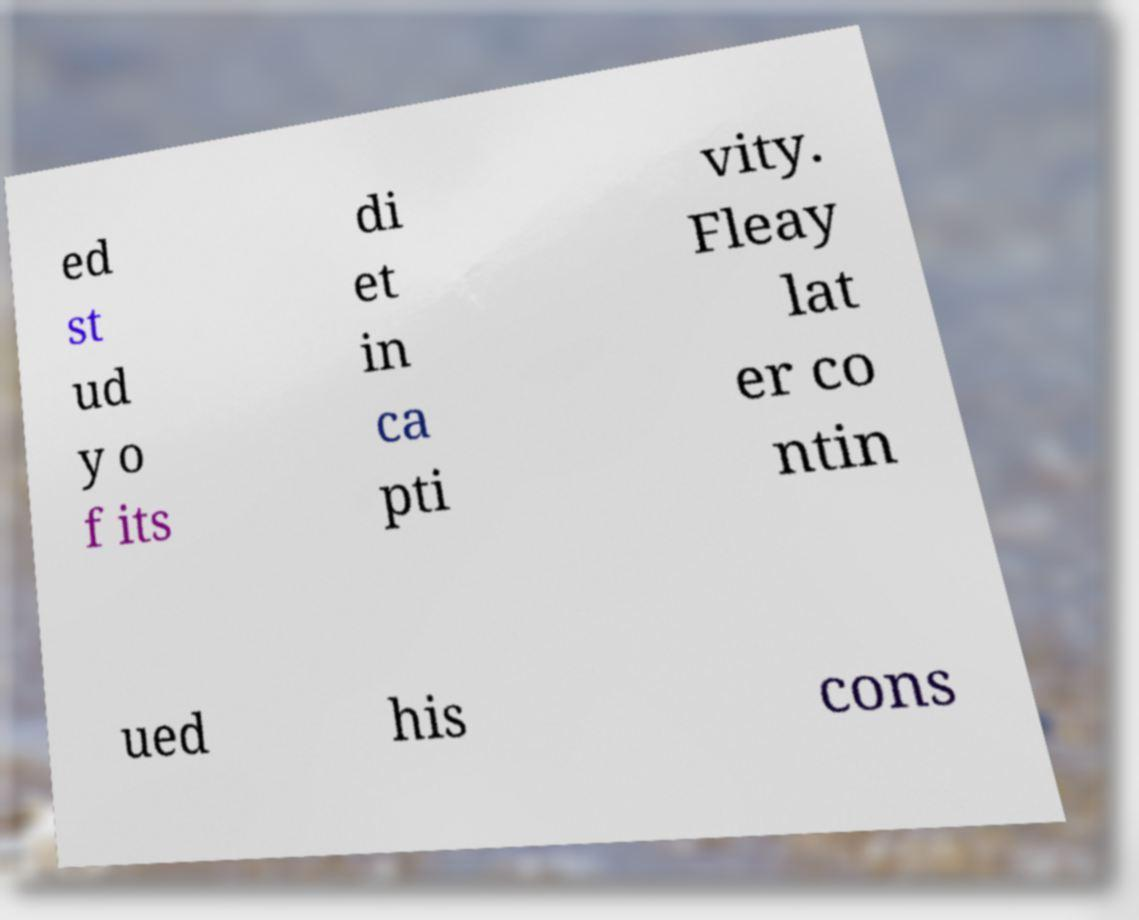Please identify and transcribe the text found in this image. ed st ud y o f its di et in ca pti vity. Fleay lat er co ntin ued his cons 